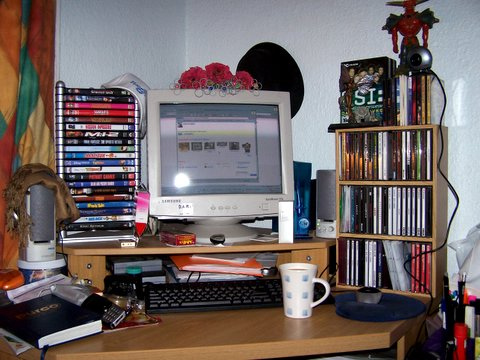<image>Where are the pencils? I am not sure where the pencils are as responses vary. They could be on the desk or not in the image at all. Where are the pencils? I don't know where the pencils are. They could be on the desk or in the lower right corner. 